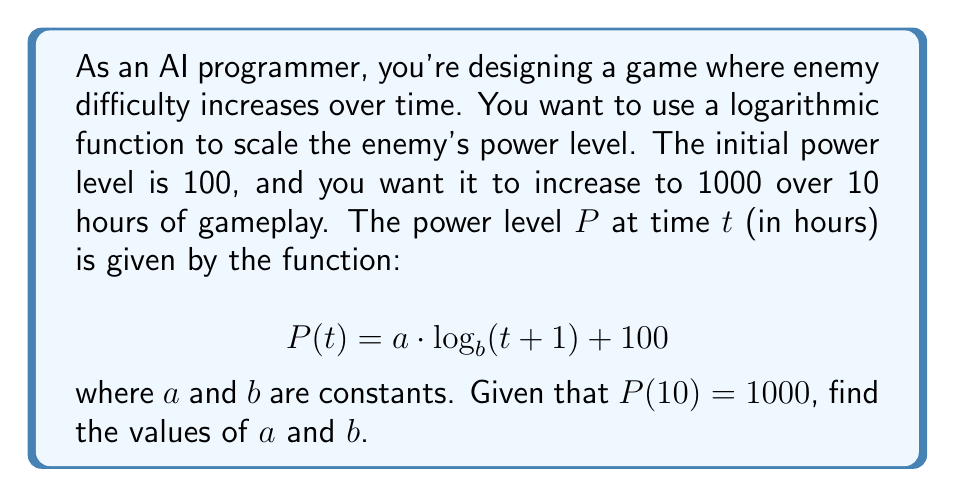Can you answer this question? Let's approach this step-by-step:

1) We know that $P(10) = 1000$, so we can substitute this into our equation:

   $$ 1000 = a \cdot \log_b(11) + 100 $$

2) Rearranging this equation:

   $$ 900 = a \cdot \log_b(11) $$

3) We need another equation to solve for both $a$ and $b$. We can use the fact that $P(0) = 100$:

   $$ 100 = a \cdot \log_b(1) + 100 $$

   This simplifies to $0 = a \cdot 0$, which is always true for any $a$.

4) Let's make an educated guess for $b$. In many games, it's common to use $e$ (Euler's number) as the base for natural growth. So let's assume $b = e$.

5) If $b = e$, then our equation becomes:

   $$ 900 = a \cdot \ln(11) $$

6) We can now solve for $a$:

   $$ a = \frac{900}{\ln(11)} \approx 390.83 $$

7) To verify, let's check if this satisfies our original condition:

   $$ P(10) = 390.83 \cdot \ln(11) + 100 \approx 1000 $$

   This checks out, confirming our solution.

Therefore, the function that describes the enemy's power level over time is:

$$ P(t) = 390.83 \cdot \ln(t+1) + 100 $$

This logarithmic function ensures that the difficulty increases rapidly at first and then more gradually, providing a balanced gameplay experience.
Answer: $a \approx 390.83$, $b = e$ 